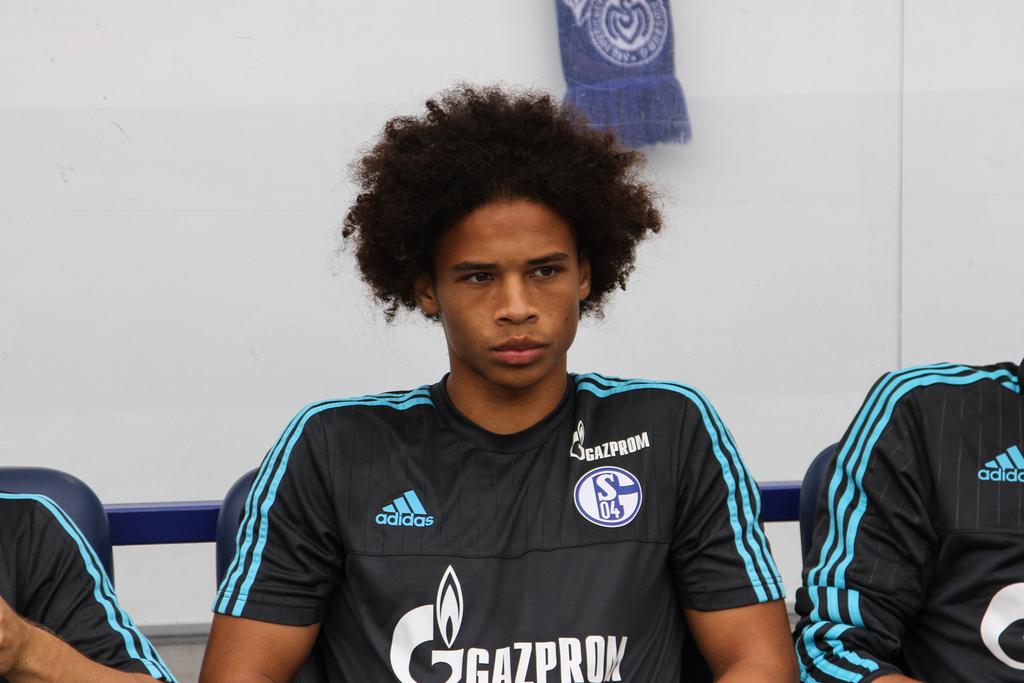Is adidas one of their sponsors?
Give a very brief answer. Yes. 